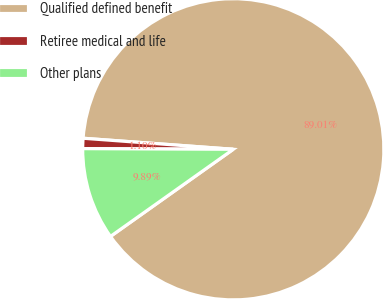<chart> <loc_0><loc_0><loc_500><loc_500><pie_chart><fcel>Qualified defined benefit<fcel>Retiree medical and life<fcel>Other plans<nl><fcel>89.01%<fcel>1.1%<fcel>9.89%<nl></chart> 